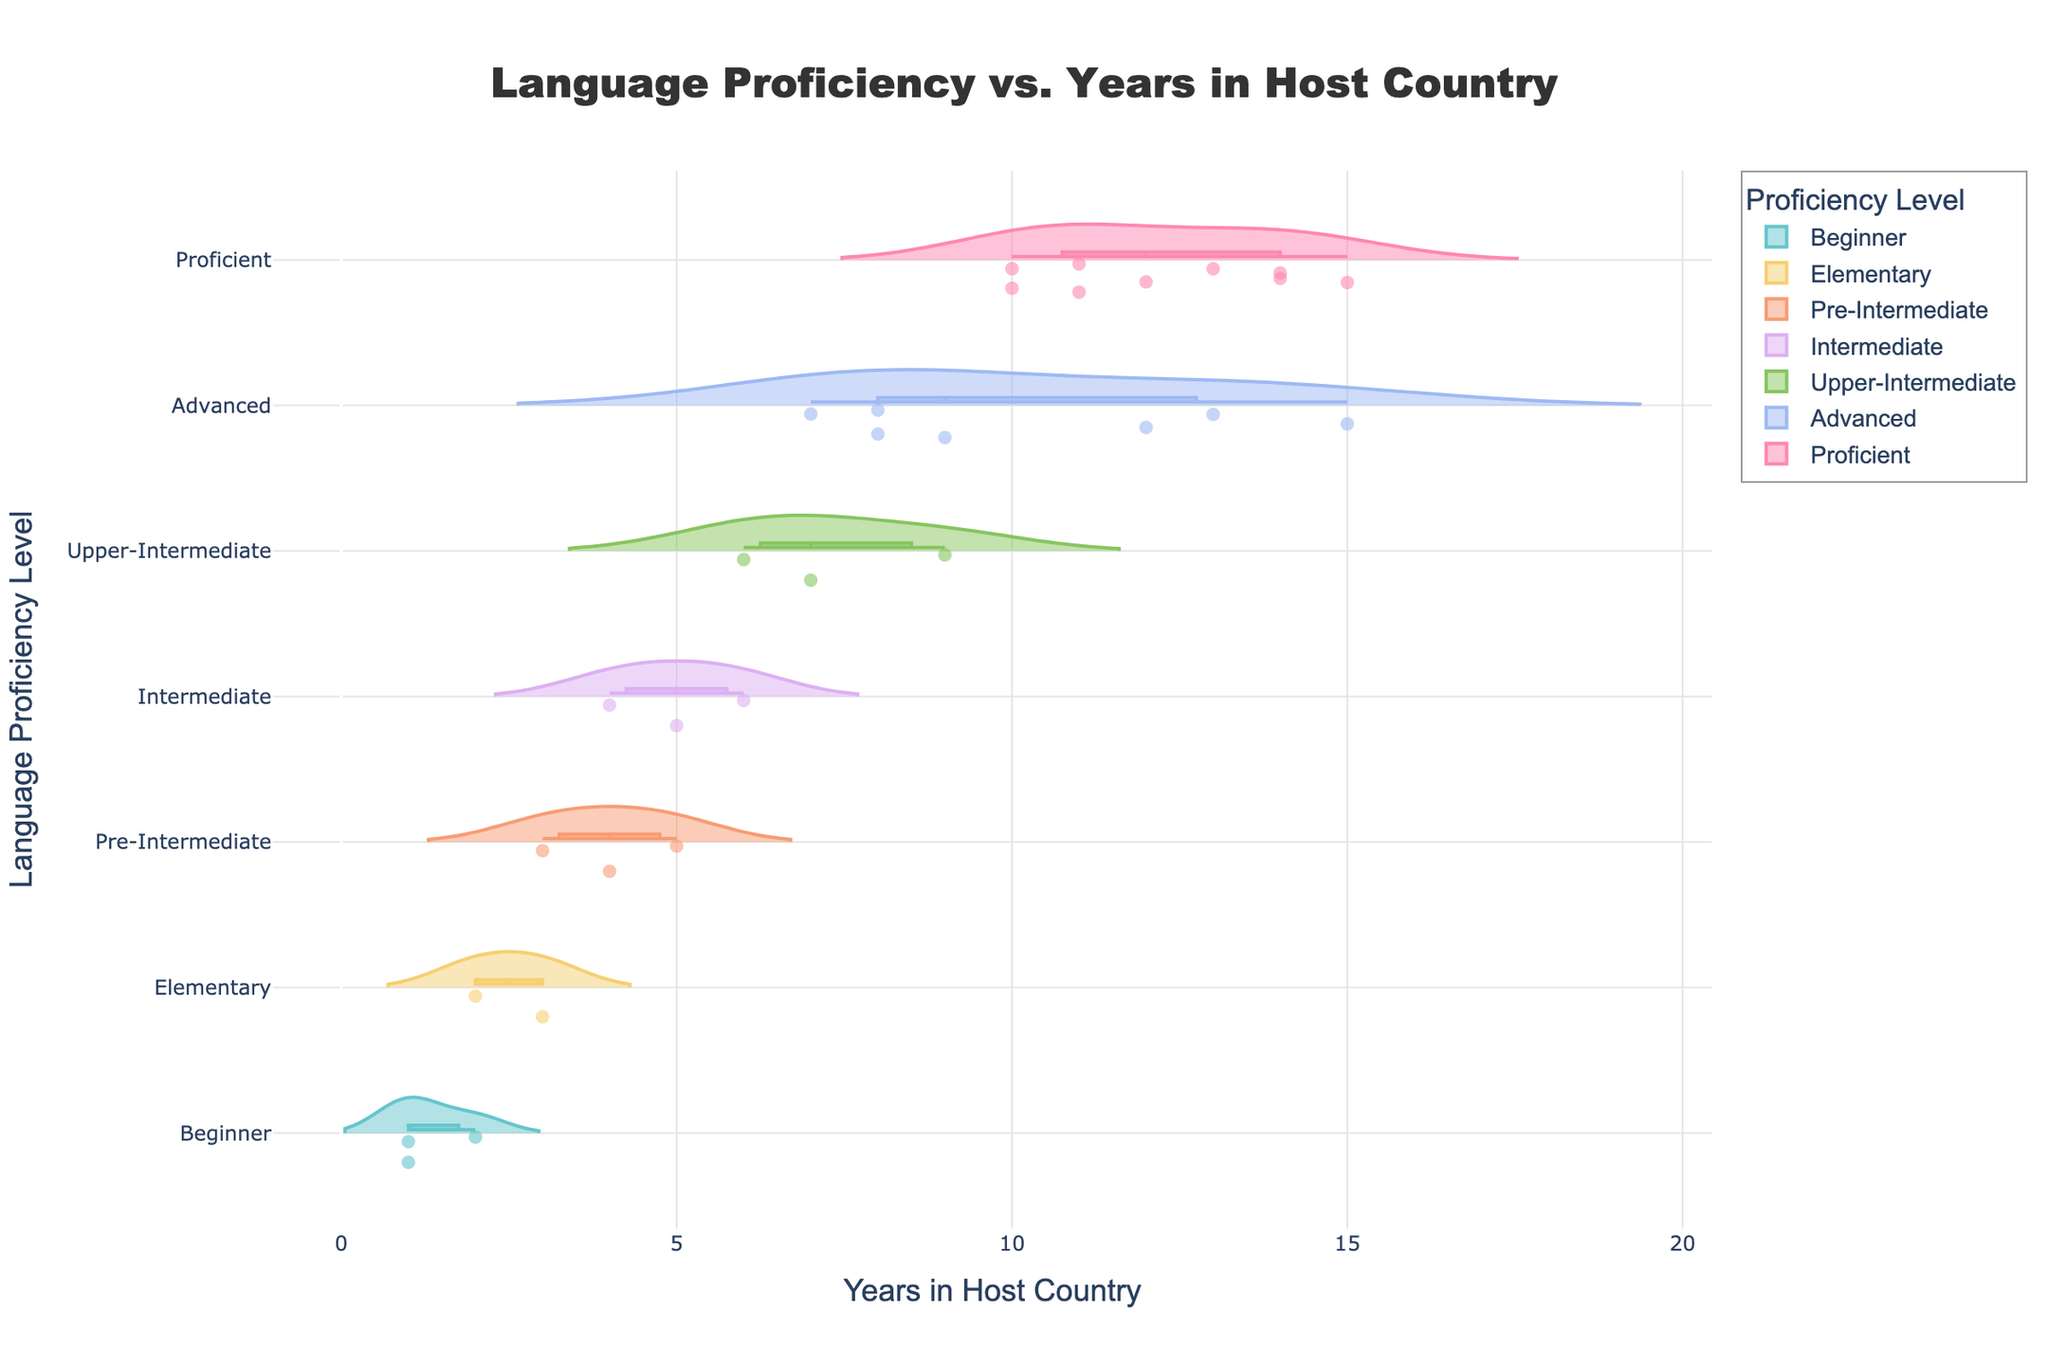what is the title of the figure? The title is typically placed at the top of the figure in larger and bolder text. The title of this figure is 'Language Proficiency vs. Years in Host Country'.
Answer: 'Language Proficiency vs. Years in Host Country' How many years in the host country does the figure consider? The range of years can be seen on the x-axis of the figure, from the smallest to the largest values. This figure considers the range from 1 to 15 years.
Answer: 1 to 15 years What is the color of the violin plot for the 'Intermediate' proficiency level? Each proficiency level is represented by a different color in the violin plot. The 'Intermediate' proficiency level is colored in the fourth color from the palette used.
Answer: Fourth color from the palette Describe the distribution of 'Proficient' proficiency levels in terms of years spent in the host country. The 'Proficient' proficiency level can be seen toward the higher end of the y-axis. Observing the distribution, the violin plot for 'Proficient' shows it primarily in years ranging from about 10 to 15.
Answer: Primarily in years 10 to 15 What proficiency levels do people achieve after 3 years in the host country? To determine the proficiency levels after 3 years, locate '3' on the x-axis and see which violin plots intersect with this line. The levels are 'Pre-Intermediate' and 'Elementary'.
Answer: 'Pre-Intermediate' and 'Elementary' Is there a general trend in language proficiency levels as the number of years in the host country increases? Observing the progression of proficiency levels from left to right across the x-axis, there is a trend showing an increase from 'Beginner' to 'Proficient' as years increase.
Answer: Increase from 'Beginner' to 'Proficient' How many proficiency levels can be identified in the figure? Count the distinct categories on the y-axis representing language proficiency levels which are: Beginner, Elementary, Pre-Intermediate, Intermediate, Upper-Intermediate, Advanced, and Proficient.
Answer: 7 proficiency levels Which proficiency level has the most condensed range of years in the host country? Look for the violin plot with the narrowest width in terms of years on the x-axis, which corresponds to the 'Proficient' level.
Answer: 'Proficient' Compare the proficiency levels at 5 years versus 10 years in the host country. At 5 years, the proficiency levels range from 'Pre-Intermediate' to 'Intermediate'. At 10 years, levels range from 'Proficient' to 'Advanced'. There is a clear shift towards higher proficiency.
Answer: Shift towards higher proficiency 